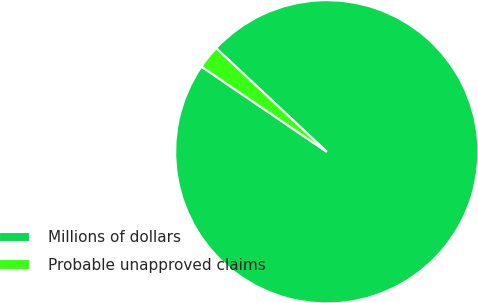Convert chart to OTSL. <chart><loc_0><loc_0><loc_500><loc_500><pie_chart><fcel>Millions of dollars<fcel>Probable unapproved claims<nl><fcel>97.52%<fcel>2.48%<nl></chart> 